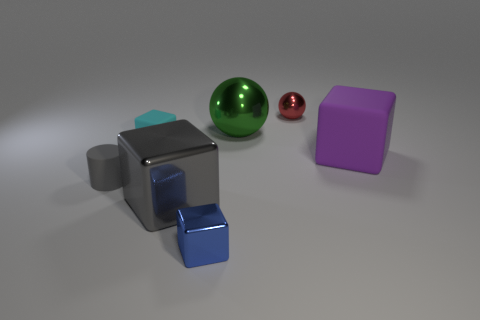Subtract 1 blocks. How many blocks are left? 3 Add 2 red metallic things. How many objects exist? 9 Subtract all balls. How many objects are left? 5 Add 6 tiny yellow cubes. How many tiny yellow cubes exist? 6 Subtract 1 cyan blocks. How many objects are left? 6 Subtract all small cyan blocks. Subtract all big green objects. How many objects are left? 5 Add 3 small blue metallic cubes. How many small blue metallic cubes are left? 4 